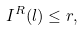Convert formula to latex. <formula><loc_0><loc_0><loc_500><loc_500>I ^ { R } ( l ) \leq r ,</formula> 